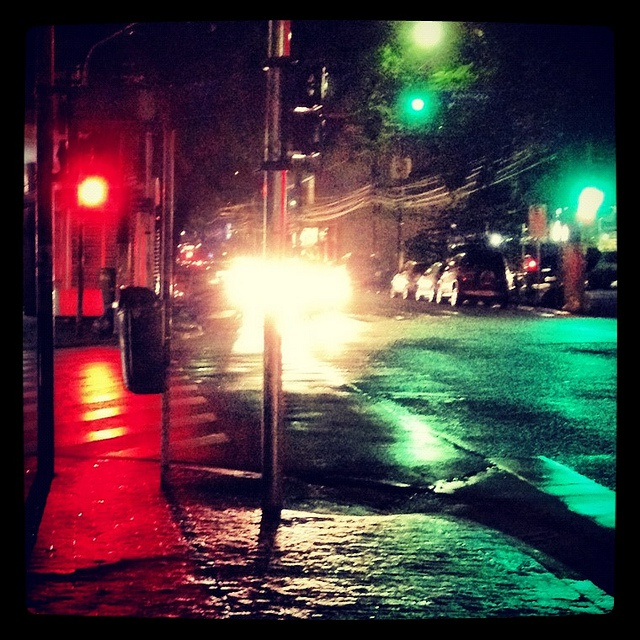Describe the objects in this image and their specific colors. I can see car in black, lightyellow, tan, and purple tones, traffic light in black, green, aquamarine, teal, and lightgreen tones, traffic light in black, lightyellow, khaki, and red tones, traffic light in black, gray, and purple tones, and car in black, brown, lightyellow, and tan tones in this image. 